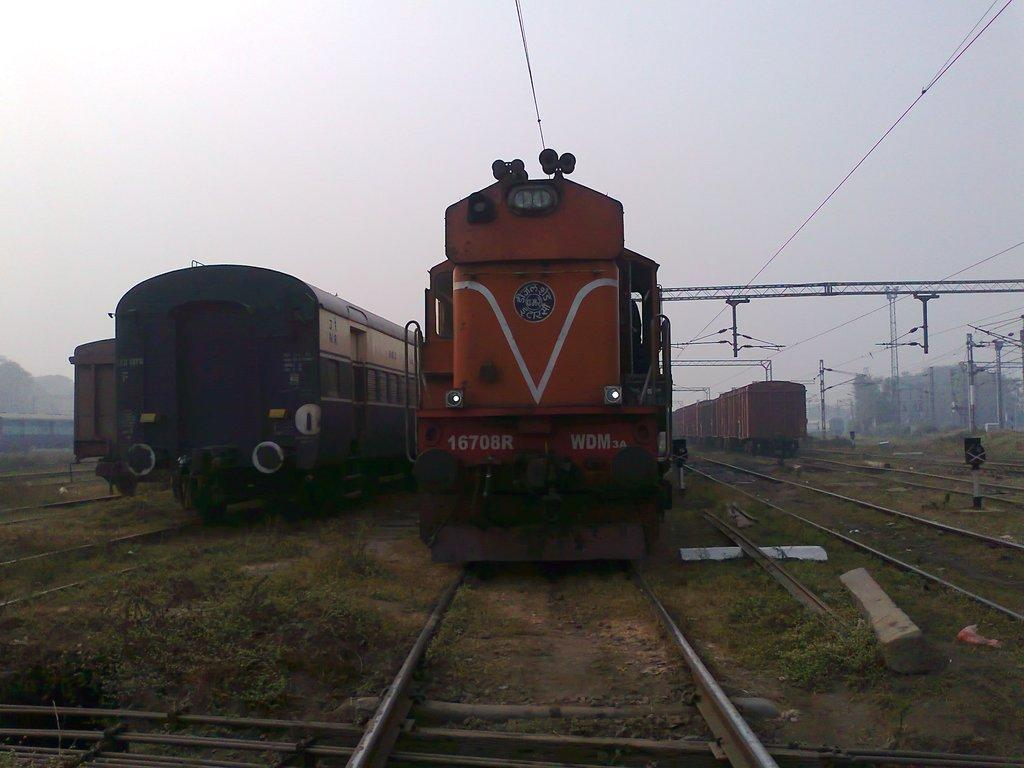What type of vehicles can be seen on the tracks in the image? There are locomotives on the tracks in the image. What type of vegetation is visible in the image? Grass and trees are present in the image. What type of structures can be seen in the image? Iron bars, electric poles, and buildings are visible in the image. What type of infrastructure is present in the image? Electric cables are present in the image. What can be seen in the background of the image? Buildings and the sky are visible in the background of the image. Where is the nest located in the image? There is no nest present in the image. What type of food is the locomotive holding in its hands in the image? Locomotives do not have hands, and there is no food present in the image. 